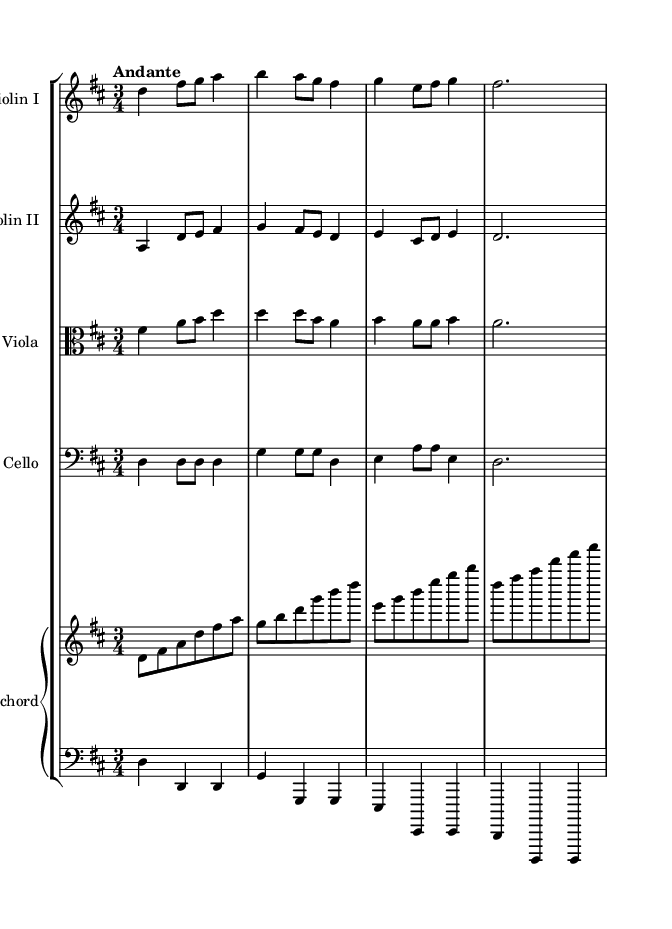What is the key signature of this music? The key signature indicates D major, which has two sharps (F# and C#). This can be confirmed by looking at the key signature at the beginning of the score.
Answer: D major What is the time signature of this music? The time signature is 3/4, which can be seen at the beginning of the score. This means there are three beats in each measure, and the quarter note gets one beat.
Answer: 3/4 What is the tempo marking of this piece? The tempo marking is "Andante," which suggests a moderate pace. This is indicated at the start of the score following the time signature.
Answer: Andante How many instruments are featured in this piece? There are five instruments featured in this piece, which can be determined by counting the different staves: two violins, one viola, one cello, and one harpsichord (with two staves for right and left hands).
Answer: Five What is the role of the cello in this piece? The cello provides the bass line and harmonic foundation for the music, which can be understood by analyzing the rhythmic and melodic structure in the cello part that supports the upper strings and maintains the tempo.
Answer: Bass line What is the primary texture of this Baroque chamber music? The texture is primarily polyphonic, as evidenced by the interweaving melodies of the different instruments, which is a characteristic feature of Baroque music. Each instrument plays a distinct line, contributing to a rich harmonic structure.
Answer: Polyphonic Which musical era does this piece represent? This piece represents the Baroque era, characterized by its ornate musical style, use of ornamentation, and contrast of textures, evident in the intricacies of the instrument parts and the overall composition style.
Answer: Baroque 